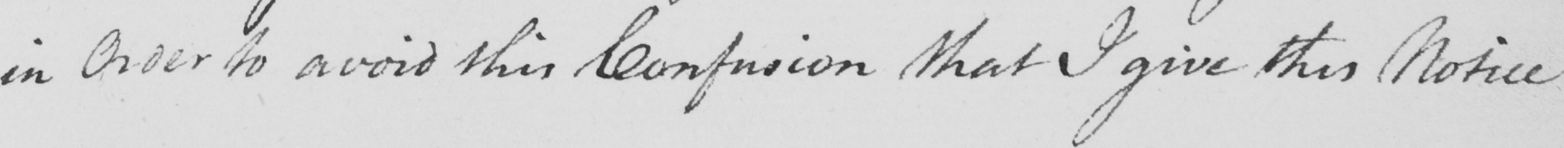Transcribe the text shown in this historical manuscript line. in Order to avoid this Confusion that I give this Notice 